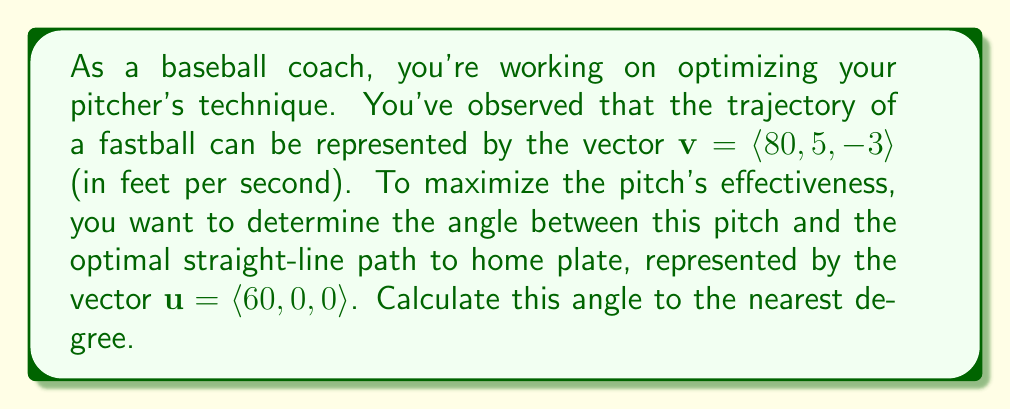Help me with this question. To solve this problem, we'll use vector projection and the dot product formula. Here's a step-by-step approach:

1) The angle $\theta$ between two vectors $\mathbf{v}$ and $\mathbf{u}$ is given by the formula:

   $$\cos \theta = \frac{\mathbf{v} \cdot \mathbf{u}}{|\mathbf{v}||\mathbf{u}|}$$

2) First, let's calculate the dot product $\mathbf{v} \cdot \mathbf{u}$:
   
   $$\mathbf{v} \cdot \mathbf{u} = 80(60) + 5(0) + (-3)(0) = 4800$$

3) Next, we need to calculate the magnitudes of $\mathbf{v}$ and $\mathbf{u}$:

   $$|\mathbf{v}| = \sqrt{80^2 + 5^2 + (-3)^2} = \sqrt{6434} \approx 80.21$$
   $$|\mathbf{u}| = \sqrt{60^2 + 0^2 + 0^2} = 60$$

4) Now we can substitute these values into our formula:

   $$\cos \theta = \frac{4800}{80.21 \times 60} \approx 0.9972$$

5) To find $\theta$, we take the inverse cosine (arccos) of both sides:

   $$\theta = \arccos(0.9972) \approx 0.0748 \text{ radians}$$

6) Convert radians to degrees:

   $$\theta \approx 0.0748 \times \frac{180}{\pi} \approx 4.29^{\circ}$$

7) Rounding to the nearest degree:

   $$\theta \approx 4^{\circ}$$

This angle represents the deviation of the pitch from the optimal straight-line path to home plate.
Answer: The angle between the pitch trajectory and the optimal path is approximately 4°. 